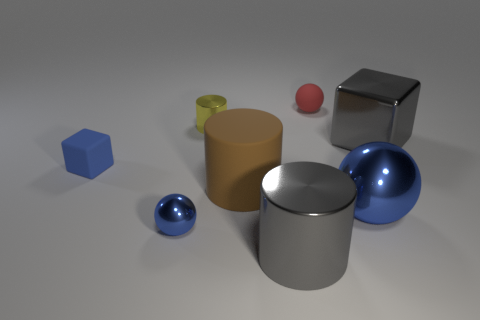Are there fewer big objects on the right side of the large metallic cylinder than big blue balls behind the blue rubber cube?
Your answer should be very brief. No. What number of balls are either big objects or big blue shiny objects?
Give a very brief answer. 1. Do the small object left of the small blue metallic object and the tiny ball that is in front of the large rubber cylinder have the same material?
Your response must be concise. No. The yellow object that is the same size as the red sphere is what shape?
Your response must be concise. Cylinder. What number of other objects are there of the same color as the big rubber object?
Your answer should be compact. 0. What number of brown objects are big things or small balls?
Provide a short and direct response. 1. There is a large gray object that is to the right of the gray cylinder; does it have the same shape as the big gray object in front of the large blue metallic thing?
Your answer should be very brief. No. How many other objects are the same material as the small blue block?
Give a very brief answer. 2. Is there a red sphere on the left side of the object that is behind the cylinder that is on the left side of the large brown matte cylinder?
Offer a very short reply. No. Is the big blue sphere made of the same material as the blue cube?
Offer a very short reply. No. 